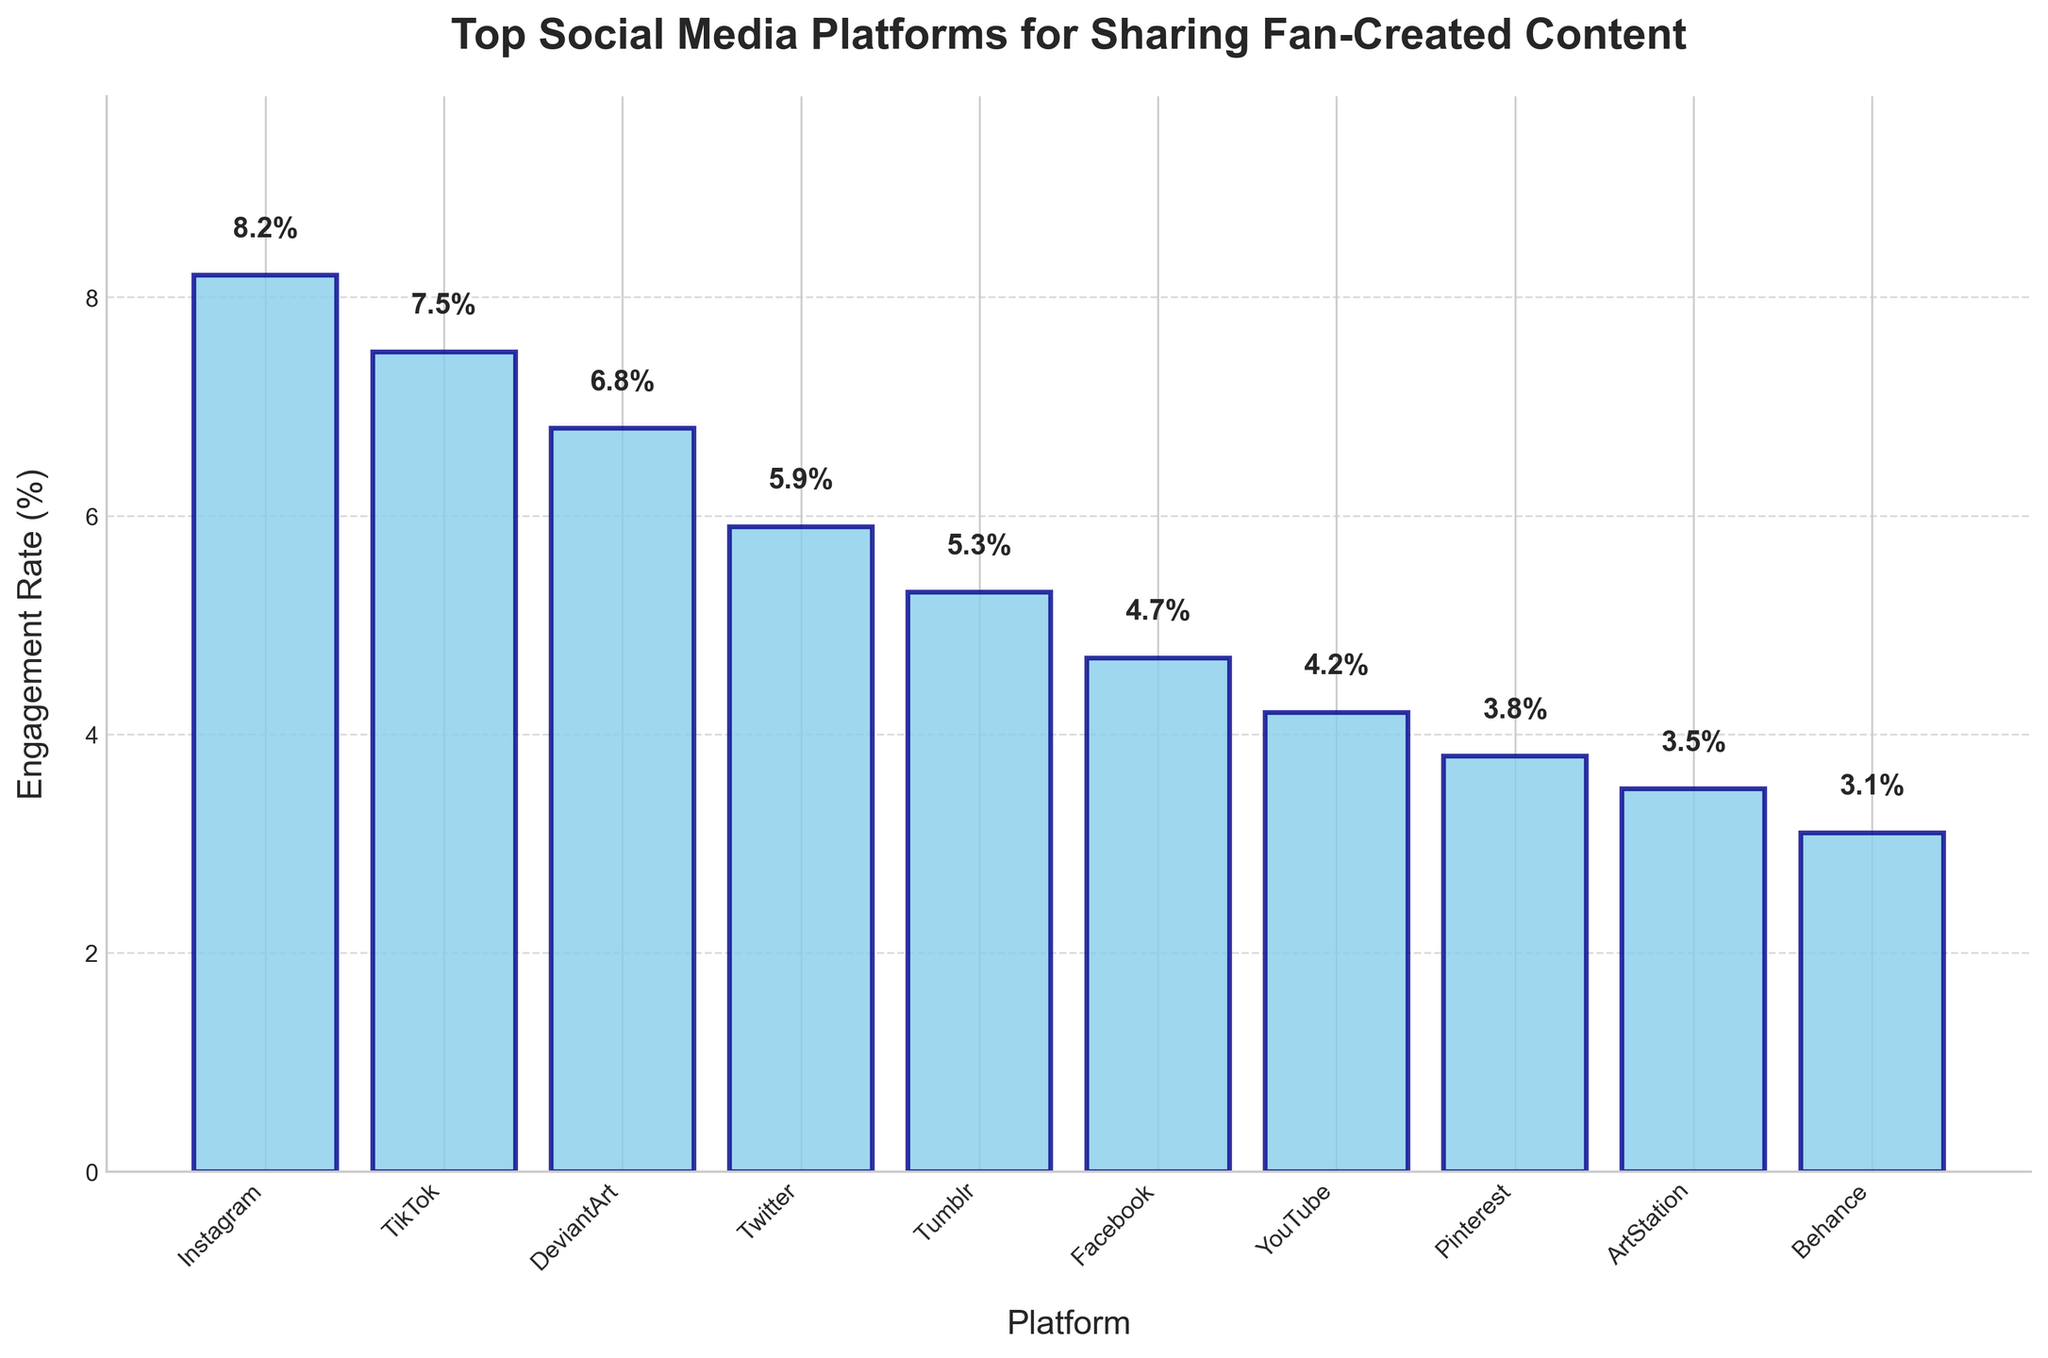What is the engagement rate of the platform with the highest engagement rate? The platform with the highest bar has an engagement rate label of 8.2%, which is Instagram.
Answer: 8.2% Which platform has a lower engagement rate, Tumblr or Facebook? Comparing the heights of the bars, Tumblr has an engagement rate of 5.3% while Facebook has an engagement rate of 4.7%.
Answer: Facebook What is the difference in engagement rates between TikTok and YouTube? TikTok has an engagement rate of 7.5%, and YouTube has an engagement rate of 4.2%. The difference is 7.5% - 4.2%.
Answer: 3.3% Which platform has the smallest engagement rate? The bar with the smallest height represents Behance, which has an engagement rate of 3.1%.
Answer: Behance How many platforms have an engagement rate above 5%? Count the bars with engagement rates above 5%: Instagram (8.2%), TikTok (7.5%), DeviantArt (6.8%), Twitter (5.9%), and Tumblr (5.3%).
Answer: 5 What is the average engagement rate of the top three platforms? The engagement rates of the top three platforms are Instagram (8.2%), TikTok (7.5%), and DeviantArt (6.8%). The average is (8.2 + 7.5 + 6.8) / 3.
Answer: 7.5% What is the total engagement rate of all platforms combined? Sum the engagement rates: 8.2 + 7.5 + 6.8 + 5.9 + 5.3 + 4.7 + 4.2 + 3.8 + 3.5 + 3.1.
Answer: 53 Which platform is ranked 5th in terms of engagement rate? According to the bar heights, Tumblr with an engagement rate of 5.3% is ranked 5th.
Answer: Tumblr What is the range of engagement rates shown in the chart? The range is calculated by subtracting the smallest engagement rate (Behance, 3.1%) from the largest engagement rate (Instagram, 8.2%).
Answer: 5.1% Are there any platforms with engagement rates within 0.5% of each other? If so, which ones? Comparing the bars visually, Pinterest (3.8%) and ArtStation (3.5%) have engagement rates within 0.5% of each other.
Answer: Pinterest and ArtStation 